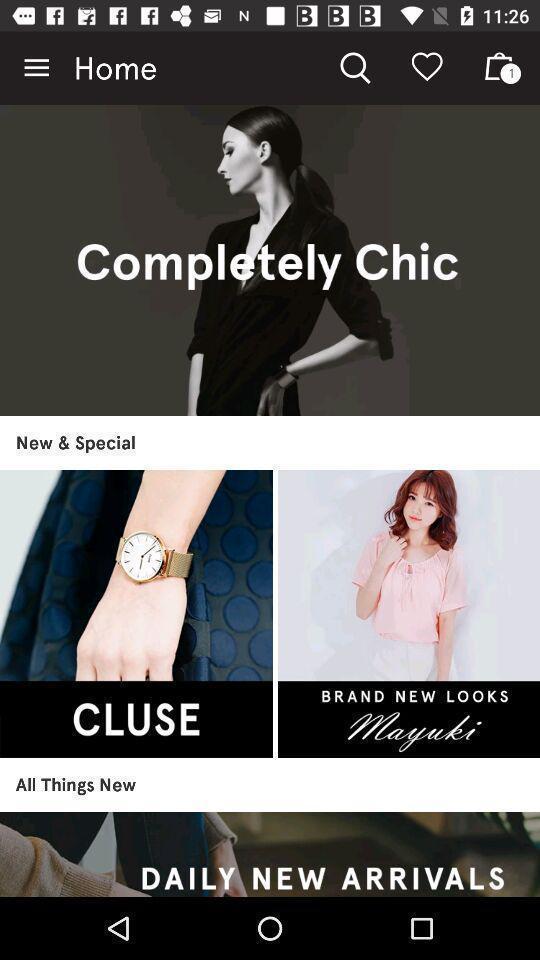Provide a detailed account of this screenshot. Screen showing a start page of an online shopping app. 